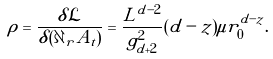Convert formula to latex. <formula><loc_0><loc_0><loc_500><loc_500>\rho = \frac { \delta \mathcal { L } } { \delta ( \partial _ { r } A _ { t } ) } = \frac { L ^ { d - 2 } } { g ^ { 2 } _ { d + 2 } } ( d - z ) \mu r ^ { d - z } _ { 0 } .</formula> 